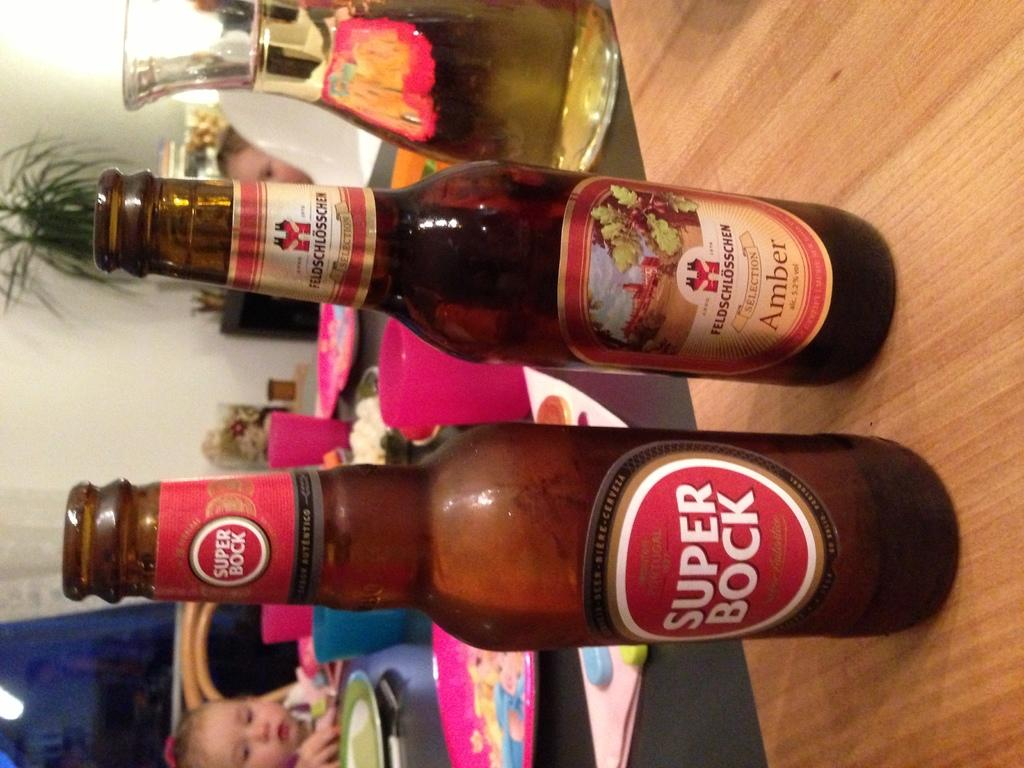How many bottles are on the table in the image? There are two bottles on the table in the image. What else can be found on the table besides the bottles? There is a jug filled with liquid and a plate on the table. What is the baby doing in the image? The baby is sitting on a chair in the image. Where is the baby positioned in relation to the table? The baby is in front of the table. What type of bone is visible on the table in the image? There is no bone present on the table in the image. What color is the light bulb hanging above the table in the image? There is no light bulb present in the image. 